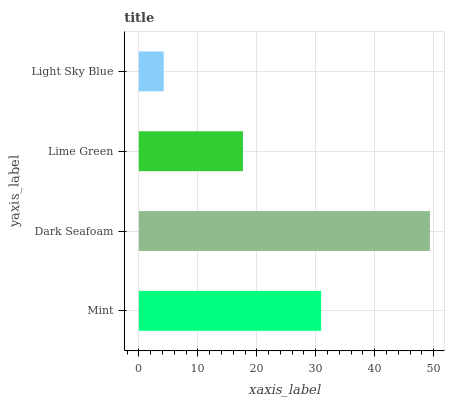Is Light Sky Blue the minimum?
Answer yes or no. Yes. Is Dark Seafoam the maximum?
Answer yes or no. Yes. Is Lime Green the minimum?
Answer yes or no. No. Is Lime Green the maximum?
Answer yes or no. No. Is Dark Seafoam greater than Lime Green?
Answer yes or no. Yes. Is Lime Green less than Dark Seafoam?
Answer yes or no. Yes. Is Lime Green greater than Dark Seafoam?
Answer yes or no. No. Is Dark Seafoam less than Lime Green?
Answer yes or no. No. Is Mint the high median?
Answer yes or no. Yes. Is Lime Green the low median?
Answer yes or no. Yes. Is Dark Seafoam the high median?
Answer yes or no. No. Is Light Sky Blue the low median?
Answer yes or no. No. 